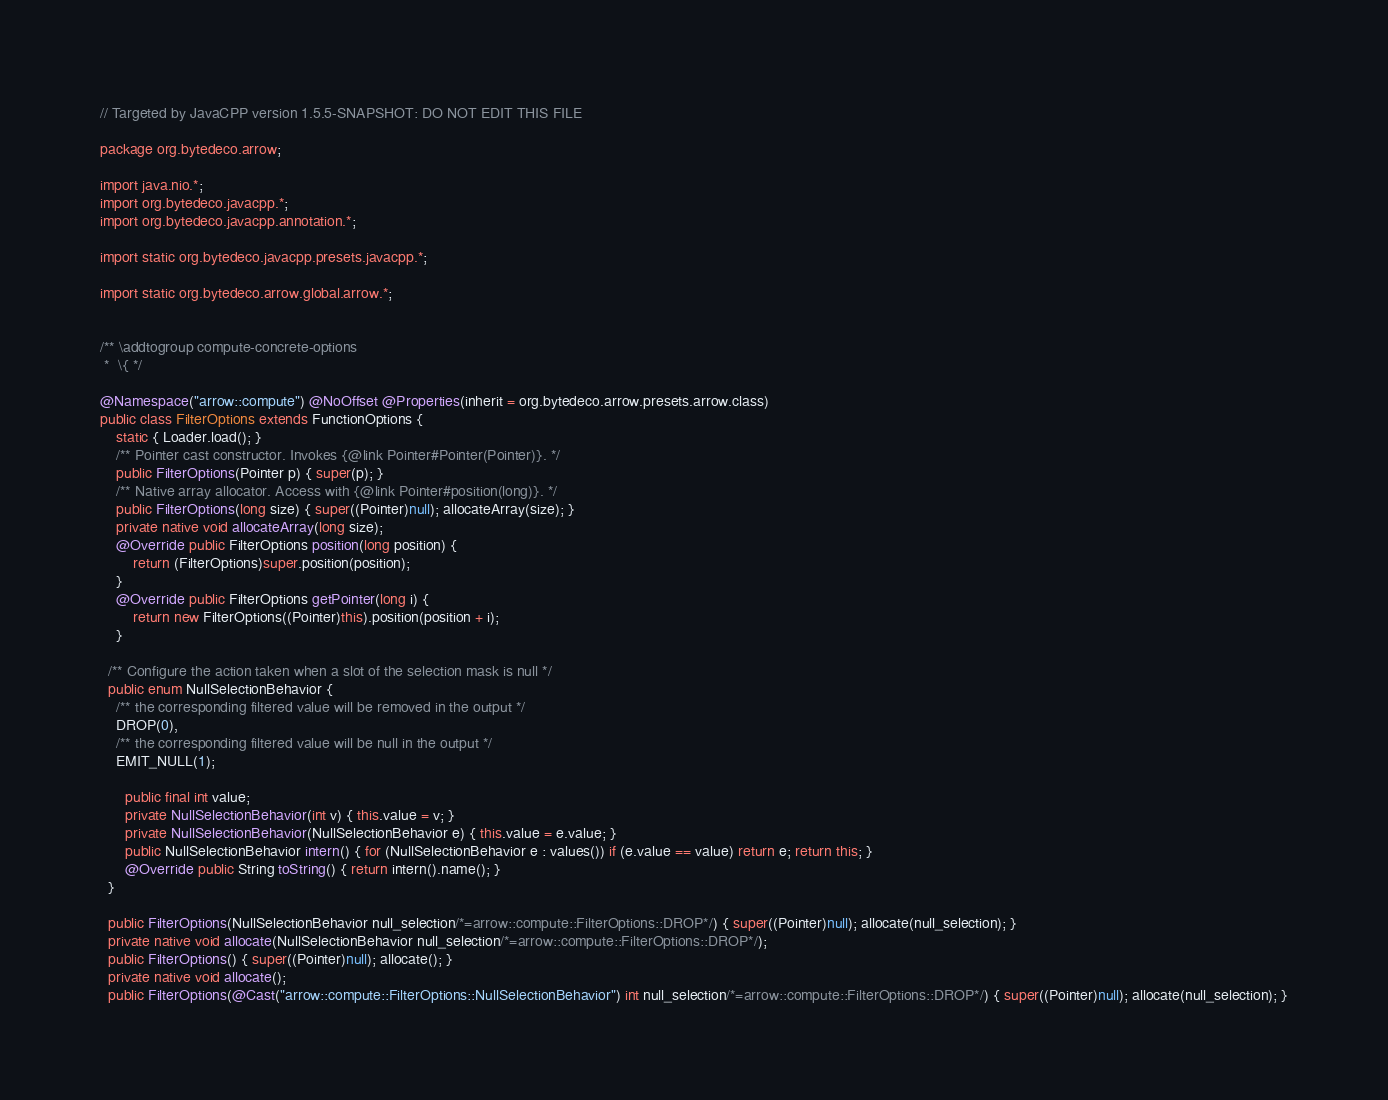Convert code to text. <code><loc_0><loc_0><loc_500><loc_500><_Java_>// Targeted by JavaCPP version 1.5.5-SNAPSHOT: DO NOT EDIT THIS FILE

package org.bytedeco.arrow;

import java.nio.*;
import org.bytedeco.javacpp.*;
import org.bytedeco.javacpp.annotation.*;

import static org.bytedeco.javacpp.presets.javacpp.*;

import static org.bytedeco.arrow.global.arrow.*;


/** \addtogroup compute-concrete-options
 *  \{ */

@Namespace("arrow::compute") @NoOffset @Properties(inherit = org.bytedeco.arrow.presets.arrow.class)
public class FilterOptions extends FunctionOptions {
    static { Loader.load(); }
    /** Pointer cast constructor. Invokes {@link Pointer#Pointer(Pointer)}. */
    public FilterOptions(Pointer p) { super(p); }
    /** Native array allocator. Access with {@link Pointer#position(long)}. */
    public FilterOptions(long size) { super((Pointer)null); allocateArray(size); }
    private native void allocateArray(long size);
    @Override public FilterOptions position(long position) {
        return (FilterOptions)super.position(position);
    }
    @Override public FilterOptions getPointer(long i) {
        return new FilterOptions((Pointer)this).position(position + i);
    }

  /** Configure the action taken when a slot of the selection mask is null */
  public enum NullSelectionBehavior {
    /** the corresponding filtered value will be removed in the output */
    DROP(0),
    /** the corresponding filtered value will be null in the output */
    EMIT_NULL(1);

      public final int value;
      private NullSelectionBehavior(int v) { this.value = v; }
      private NullSelectionBehavior(NullSelectionBehavior e) { this.value = e.value; }
      public NullSelectionBehavior intern() { for (NullSelectionBehavior e : values()) if (e.value == value) return e; return this; }
      @Override public String toString() { return intern().name(); }
  }

  public FilterOptions(NullSelectionBehavior null_selection/*=arrow::compute::FilterOptions::DROP*/) { super((Pointer)null); allocate(null_selection); }
  private native void allocate(NullSelectionBehavior null_selection/*=arrow::compute::FilterOptions::DROP*/);
  public FilterOptions() { super((Pointer)null); allocate(); }
  private native void allocate();
  public FilterOptions(@Cast("arrow::compute::FilterOptions::NullSelectionBehavior") int null_selection/*=arrow::compute::FilterOptions::DROP*/) { super((Pointer)null); allocate(null_selection); }</code> 